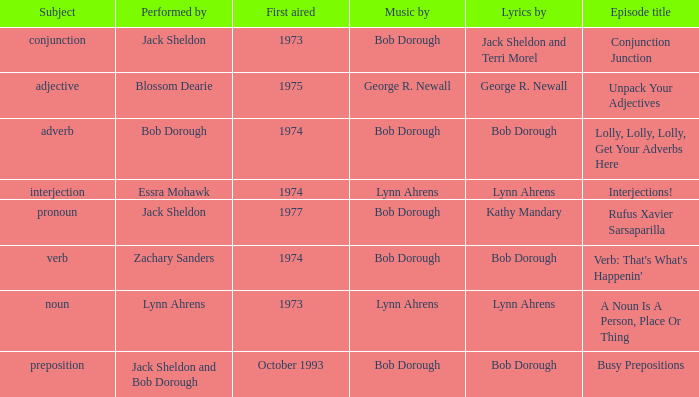When interjection is the subject who are the lyrics by? Lynn Ahrens. 